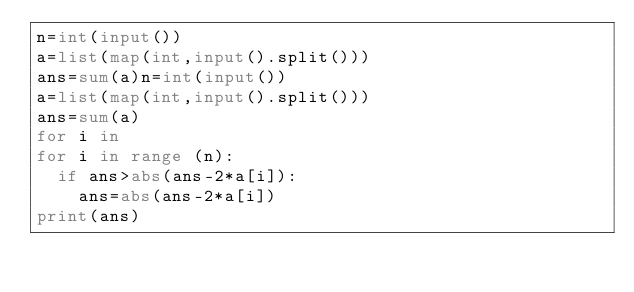Convert code to text. <code><loc_0><loc_0><loc_500><loc_500><_Python_>n=int(input())
a=list(map(int,input().split()))
ans=sum(a)n=int(input())
a=list(map(int,input().split()))
ans=sum(a)
for i in
for i in range (n):
  if ans>abs(ans-2*a[i]):
    ans=abs(ans-2*a[i])
print(ans)
</code> 